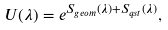<formula> <loc_0><loc_0><loc_500><loc_500>U ( \lambda ) = e ^ { S _ { g e o m } ( \lambda ) + S _ { q s t } ( \lambda ) } ,</formula> 